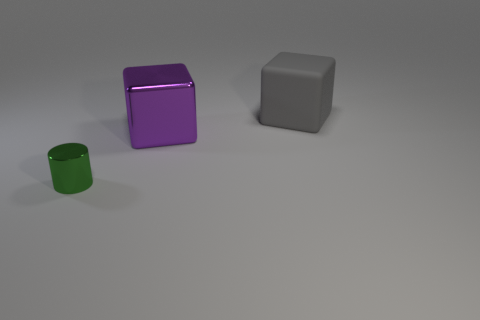Add 2 gray objects. How many objects exist? 5 Subtract all blocks. How many objects are left? 1 Add 1 purple objects. How many purple objects are left? 2 Add 3 large purple shiny things. How many large purple shiny things exist? 4 Subtract 0 red blocks. How many objects are left? 3 Subtract all small green metallic things. Subtract all small metal cylinders. How many objects are left? 1 